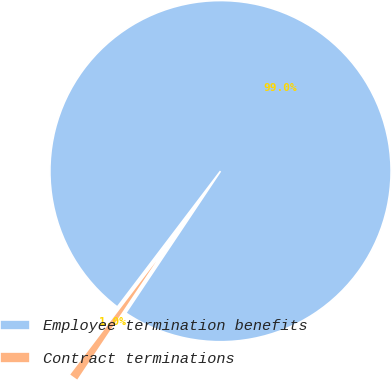Convert chart to OTSL. <chart><loc_0><loc_0><loc_500><loc_500><pie_chart><fcel>Employee termination benefits<fcel>Contract terminations<nl><fcel>99.04%<fcel>0.96%<nl></chart> 